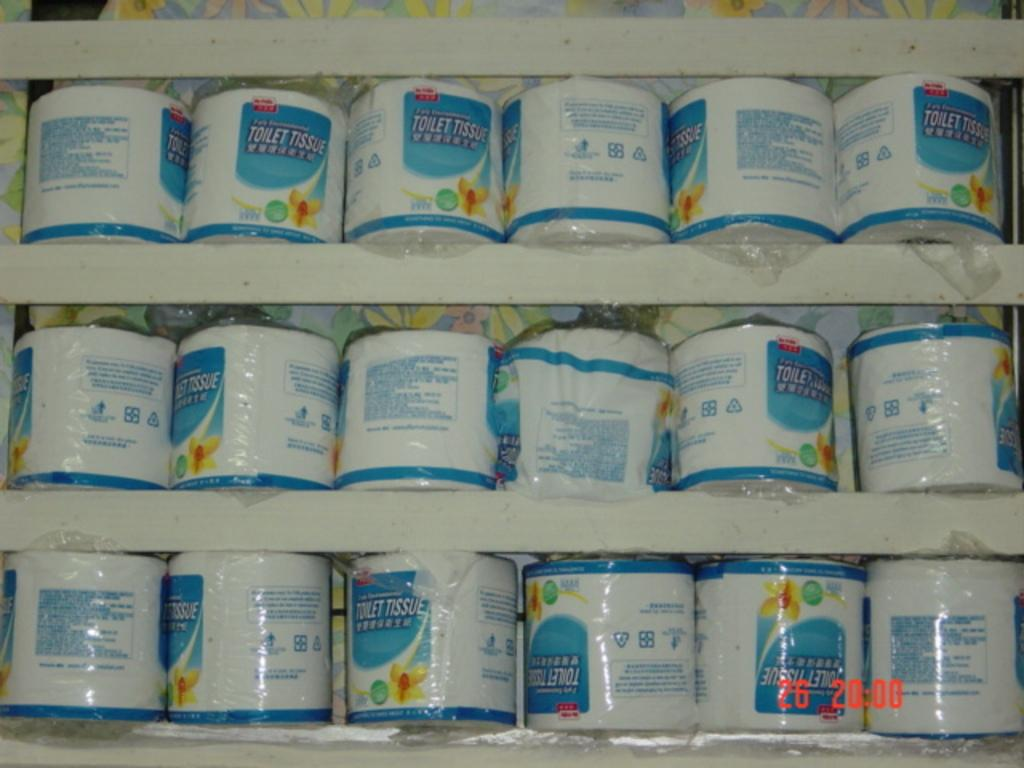<image>
Summarize the visual content of the image. Rows of toilet tissue sitting on mutliple shelves. 